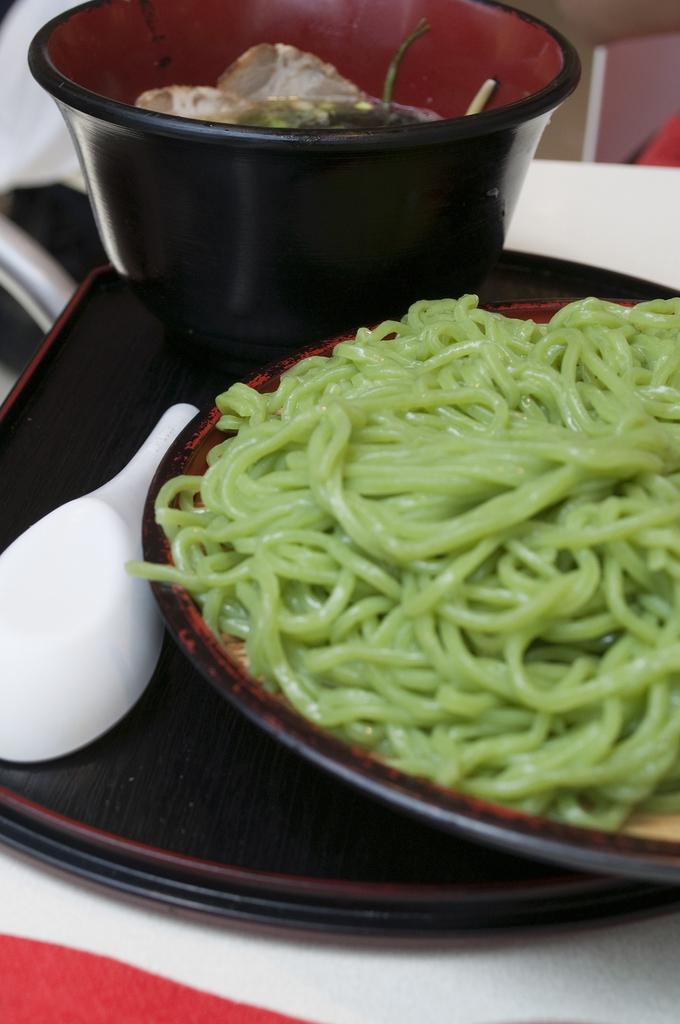Could you give a brief overview of what you see in this image? In this image there is a plate containing noodles, spoon, bowl and a tray placed on the table. 